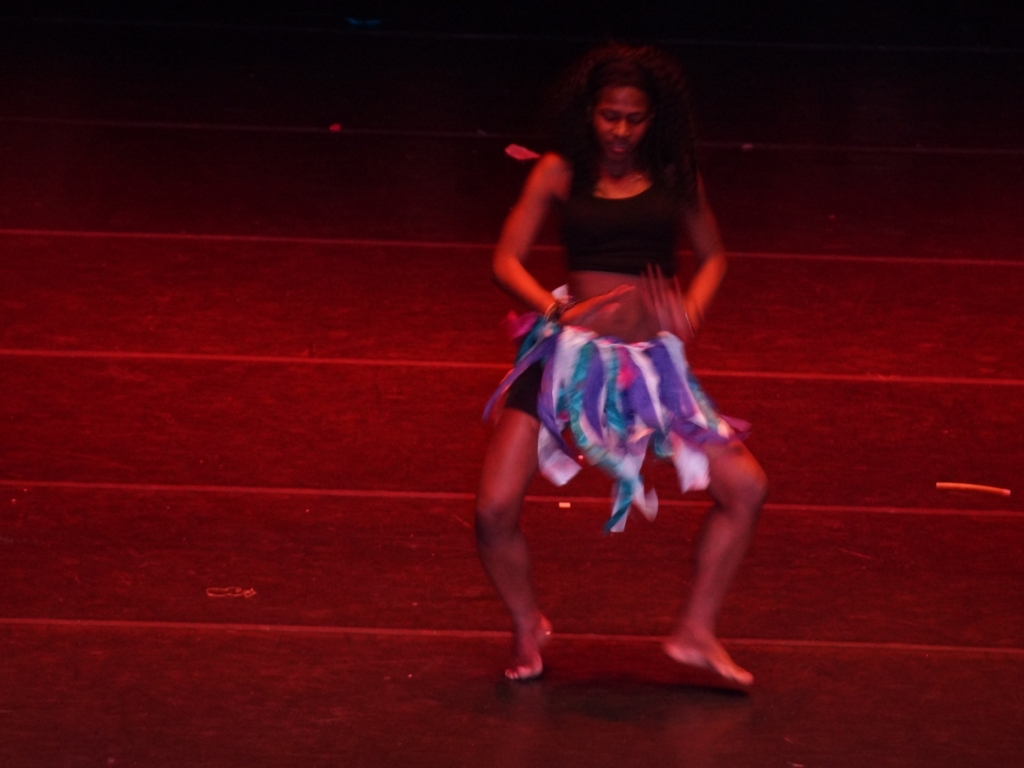Can you comment on the technique used to capture this image? Certainly, the photographer seems to have used a slower shutter speed, which allows for the motion of the dancer to be captured as a blur. This technique emphasizes the movement and is often used to convey a sense of action in photography. How does the lighting affect the mood of this photograph? The stage lighting creates a dramatic effect, focusing attention on the dancer. It enhances the dynamic nature of her performance and gives the image a theatrical atmosphere. 